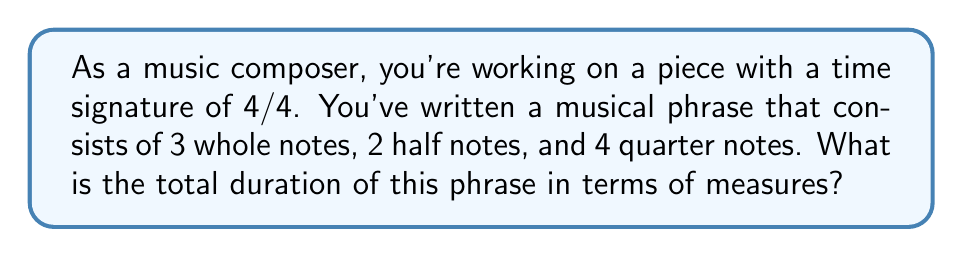Solve this math problem. Let's approach this step-by-step:

1) First, let's recall the duration of each note type in a 4/4 time signature:
   - A whole note ($\circ$) = 4 beats = 1 measure
   - A half note ($\mathbf{d}$) = 2 beats = 1/2 measure
   - A quarter note ($\blacklozenge$) = 1 beat = 1/4 measure

2) Now, let's calculate the duration of each note type in the phrase:
   - 3 whole notes: $3 \times 1 = 3$ measures
   - 2 half notes: $2 \times \frac{1}{2} = 1$ measure
   - 4 quarter notes: $4 \times \frac{1}{4} = 1$ measure

3) To find the total duration, we sum these up:
   $$\text{Total duration} = 3 + 1 + 1 = 5\text{ measures}$$

Therefore, the musical phrase lasts for 5 measures in 4/4 time.
Answer: $5\text{ measures}$ 